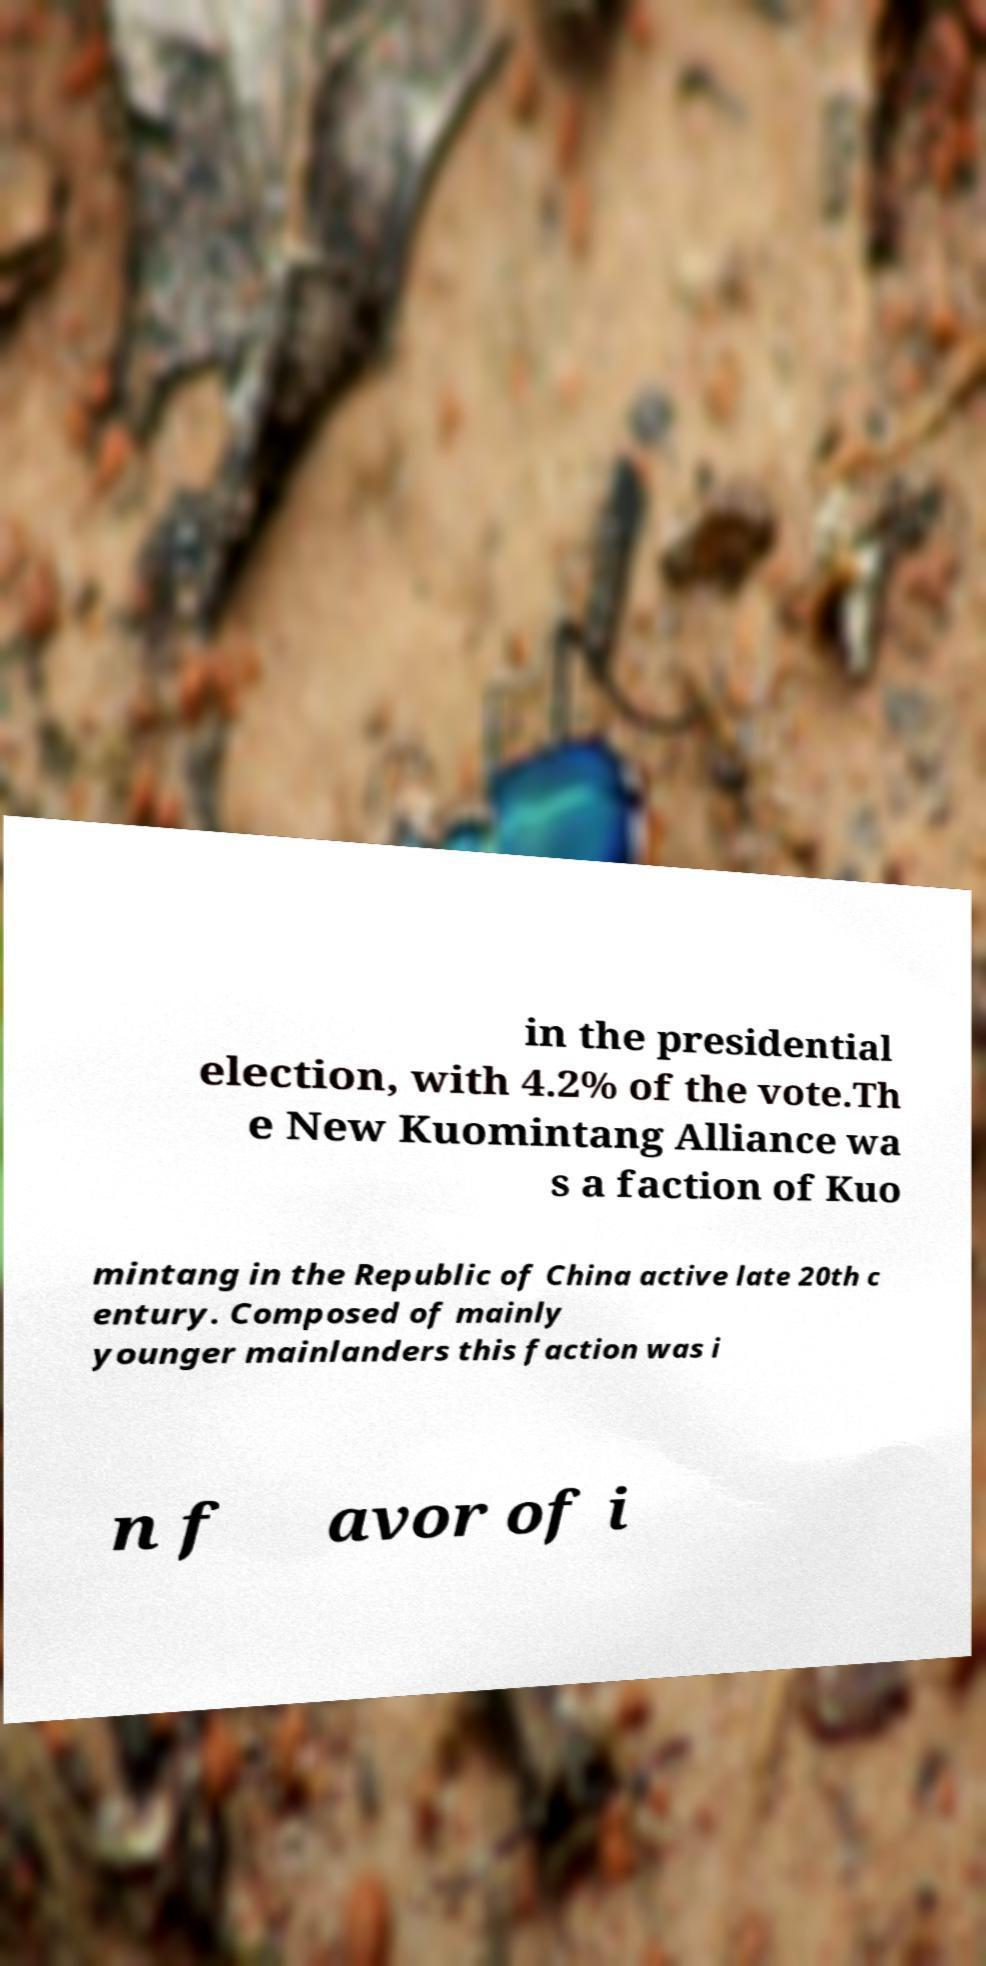Can you accurately transcribe the text from the provided image for me? in the presidential election, with 4.2% of the vote.Th e New Kuomintang Alliance wa s a faction of Kuo mintang in the Republic of China active late 20th c entury. Composed of mainly younger mainlanders this faction was i n f avor of i 